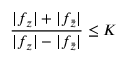<formula> <loc_0><loc_0><loc_500><loc_500>{ \frac { | f _ { z } | + | f _ { \bar { z } } | } { | f _ { z } | - | f _ { \bar { z } } | } } \leq K</formula> 